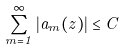Convert formula to latex. <formula><loc_0><loc_0><loc_500><loc_500>\sum _ { m = 1 } ^ { \infty } | a _ { m } ( z ) | \leq C</formula> 